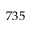Convert formula to latex. <formula><loc_0><loc_0><loc_500><loc_500>7 3 5</formula> 